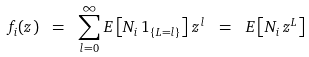<formula> <loc_0><loc_0><loc_500><loc_500>f _ { i } ( z ) \ = \ \sum _ { l = 0 } ^ { \infty } E \left [ N _ { i } \, 1 _ { \{ L = l \} } \right ] \, z ^ { l } \ = \ E \left [ N _ { i } \, z ^ { L } \right ]</formula> 